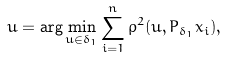<formula> <loc_0><loc_0><loc_500><loc_500>u = \arg \min _ { u \in \delta _ { 1 } } \sum _ { i = 1 } ^ { n } \rho ^ { 2 } ( u , P _ { \delta _ { 1 } } x _ { i } ) ,</formula> 